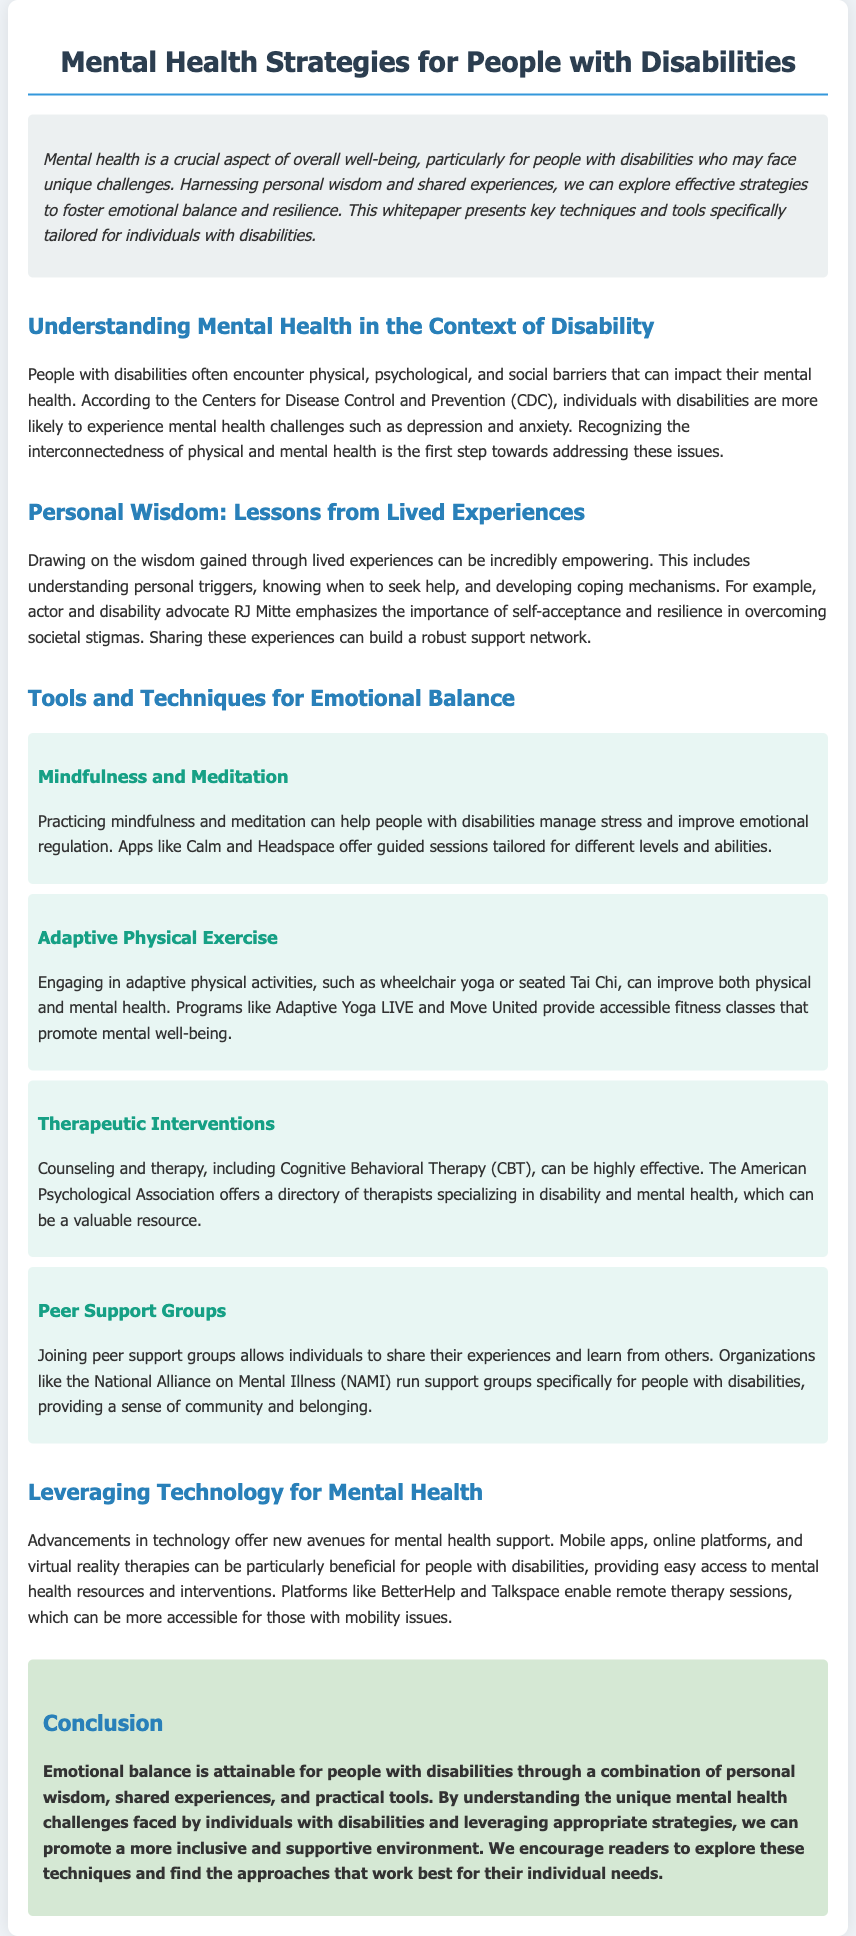What is the primary focus of the whitepaper? The primary focus is on mental health strategies specifically for people with disabilities.
Answer: Mental health strategies for people with disabilities Which organization is referenced regarding mental health challenges in people with disabilities? The CDC (Centers for Disease Control and Prevention) is cited for information on mental health challenges.
Answer: CDC Name one app mentioned for mindfulness and meditation. The document lists apps like Calm and Headspace for mindfulness and meditation.
Answer: Calm What type of exercise is recommended in the document? The document suggests engaging in adaptive physical activities such as wheelchair yoga or seated Tai Chi.
Answer: Adaptive physical activities Which therapeutic approach is highlighted as effective in the document? Cognitive Behavioral Therapy (CBT) is mentioned as a highly effective therapeutic intervention.
Answer: Cognitive Behavioral Therapy What is a benefit of joining peer support groups? Peer support groups provide a sense of community and belonging to individuals with disabilities.
Answer: Sense of community Which platform allows for remote therapy sessions? The document mentions platforms like BetterHelp and Talkspace for remote therapy sessions.
Answer: BetterHelp How can technology contribute to mental health support? Advancements in technology offer new avenues for mental health support through various online and mobile resources.
Answer: New avenues for mental health support 